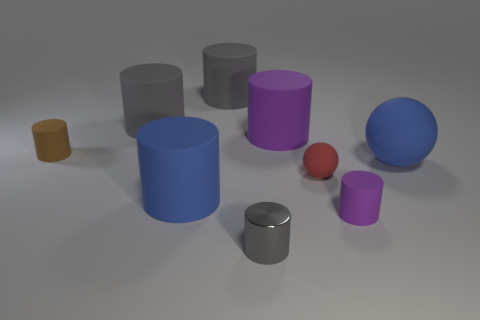How many gray cylinders must be subtracted to get 1 gray cylinders? 2 Subtract all blue balls. How many gray cylinders are left? 3 Subtract all blue cylinders. How many cylinders are left? 6 Subtract all small brown cylinders. How many cylinders are left? 6 Subtract all green cylinders. Subtract all brown cubes. How many cylinders are left? 7 Subtract all spheres. How many objects are left? 7 Add 9 big blue balls. How many big blue balls are left? 10 Add 8 big green rubber objects. How many big green rubber objects exist? 8 Subtract 0 yellow cylinders. How many objects are left? 9 Subtract all red rubber spheres. Subtract all small gray matte cylinders. How many objects are left? 8 